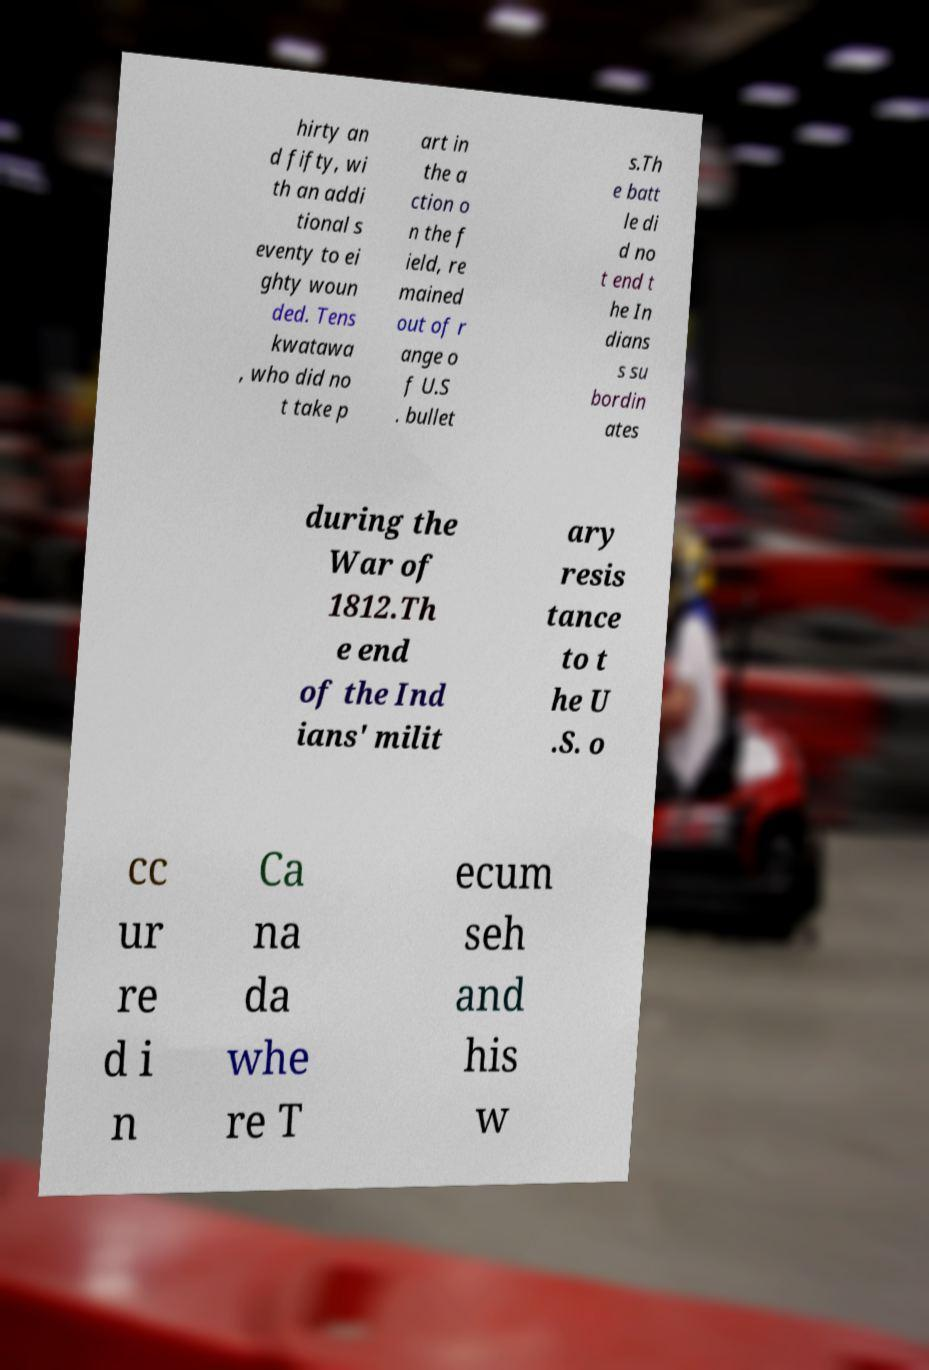Can you accurately transcribe the text from the provided image for me? hirty an d fifty, wi th an addi tional s eventy to ei ghty woun ded. Tens kwatawa , who did no t take p art in the a ction o n the f ield, re mained out of r ange o f U.S . bullet s.Th e batt le di d no t end t he In dians s su bordin ates during the War of 1812.Th e end of the Ind ians' milit ary resis tance to t he U .S. o cc ur re d i n Ca na da whe re T ecum seh and his w 